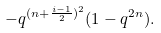<formula> <loc_0><loc_0><loc_500><loc_500>- q ^ { ( n + \frac { i - 1 } { 2 } ) ^ { 2 } } ( 1 - q ^ { 2 n } ) .</formula> 